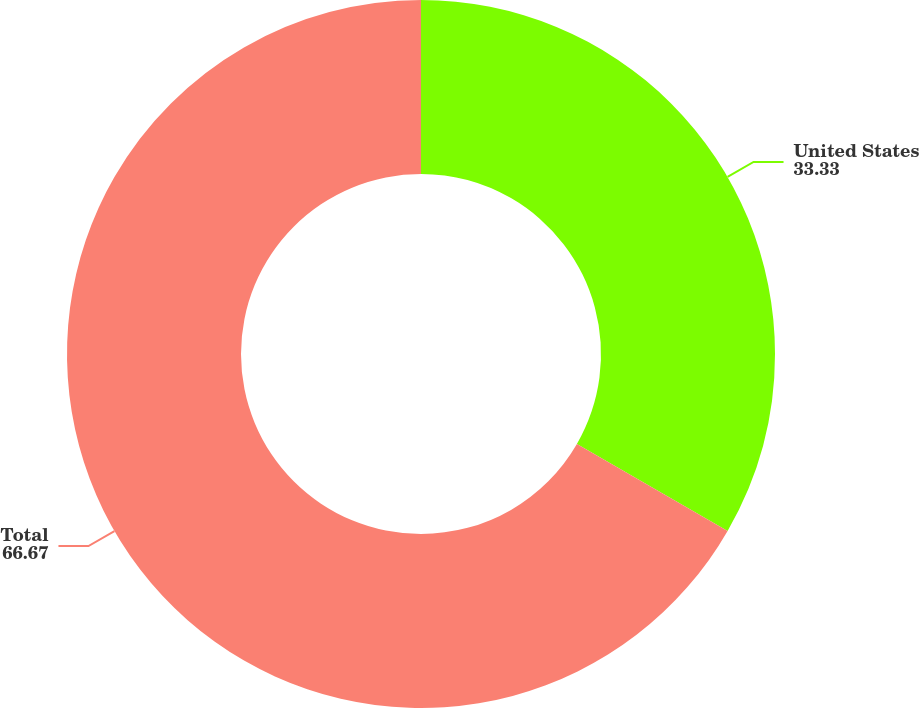Convert chart to OTSL. <chart><loc_0><loc_0><loc_500><loc_500><pie_chart><fcel>United States<fcel>Total<nl><fcel>33.33%<fcel>66.67%<nl></chart> 